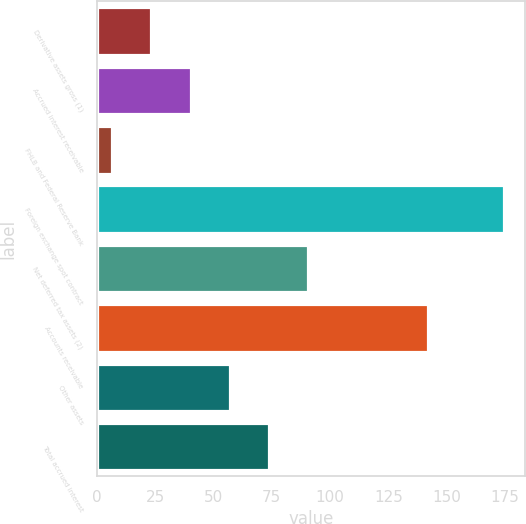<chart> <loc_0><loc_0><loc_500><loc_500><bar_chart><fcel>Derivative assets gross (1)<fcel>Accrued interest receivable<fcel>FHLB and Federal Reserve Bank<fcel>Foreign exchange spot contract<fcel>Net deferred tax assets (2)<fcel>Accounts receivable<fcel>Other assets<fcel>Total accrued interest<nl><fcel>23.33<fcel>40.16<fcel>6.5<fcel>174.8<fcel>90.65<fcel>142.2<fcel>56.99<fcel>73.82<nl></chart> 